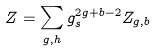Convert formula to latex. <formula><loc_0><loc_0><loc_500><loc_500>Z = \sum _ { g , h } g _ { s } ^ { 2 g + b - 2 } Z _ { g , b }</formula> 